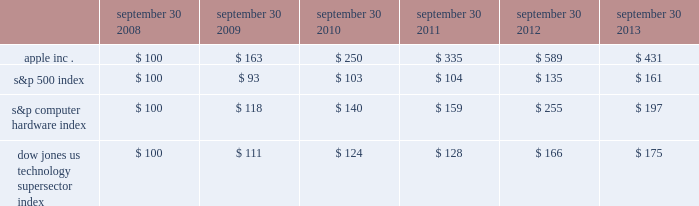Table of contents company stock performance the following graph shows a five-year comparison of cumulative total shareholder return , calculated on a dividend reinvested basis , for the company , the s&p 500 index , the s&p computer hardware index , and the dow jones u.s .
Technology supersector index .
The graph assumes $ 100 was invested in each of the company 2019s common stock , the s&p 500 index , the s&p computer hardware index , and the dow jones u.s .
Technology supersector index as of the market close on september 30 , 2008 .
Data points on the graph are annual .
Note that historic stock price performance is not necessarily indicative of future stock price performance .
Fiscal year ending september 30 .
Copyright 2013 s&p , a division of the mcgraw-hill companies inc .
All rights reserved .
Copyright 2013 dow jones & co .
All rights reserved .
*$ 100 invested on 9/30/08 in stock or index , including reinvestment of dividends .
September 30 , september 30 , september 30 , september 30 , september 30 , september 30 .

What was the cumulative change in value for apple inc . between 2008 and 2013? 
Computations: (431 - 100)
Answer: 331.0. 